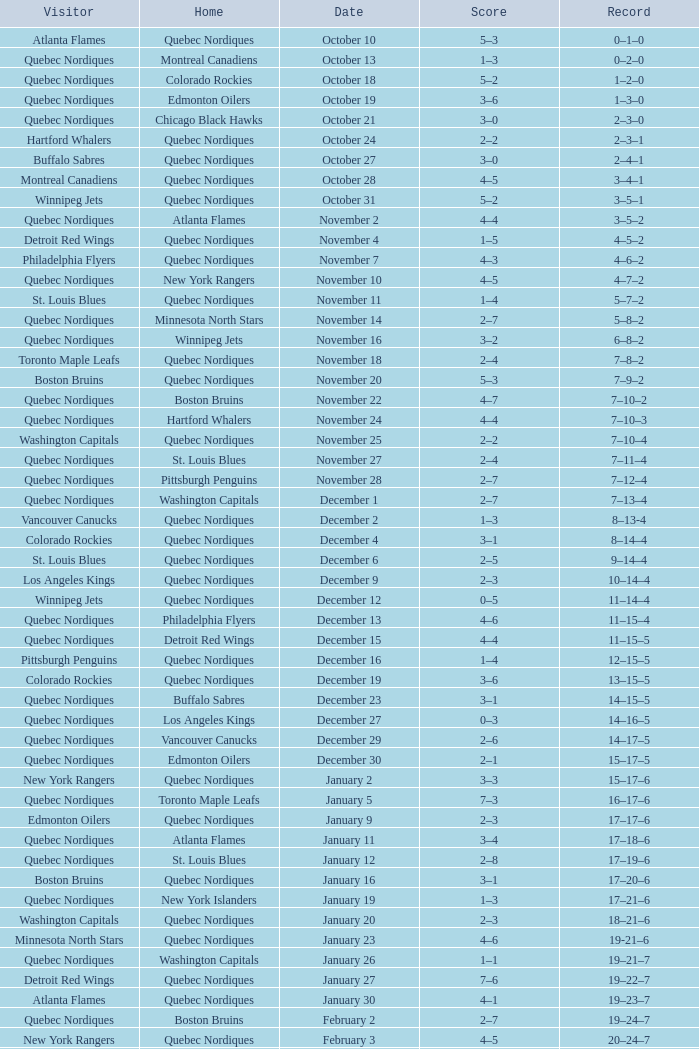Which Date has a Score of 2–7, and a Record of 5–8–2? November 14. 